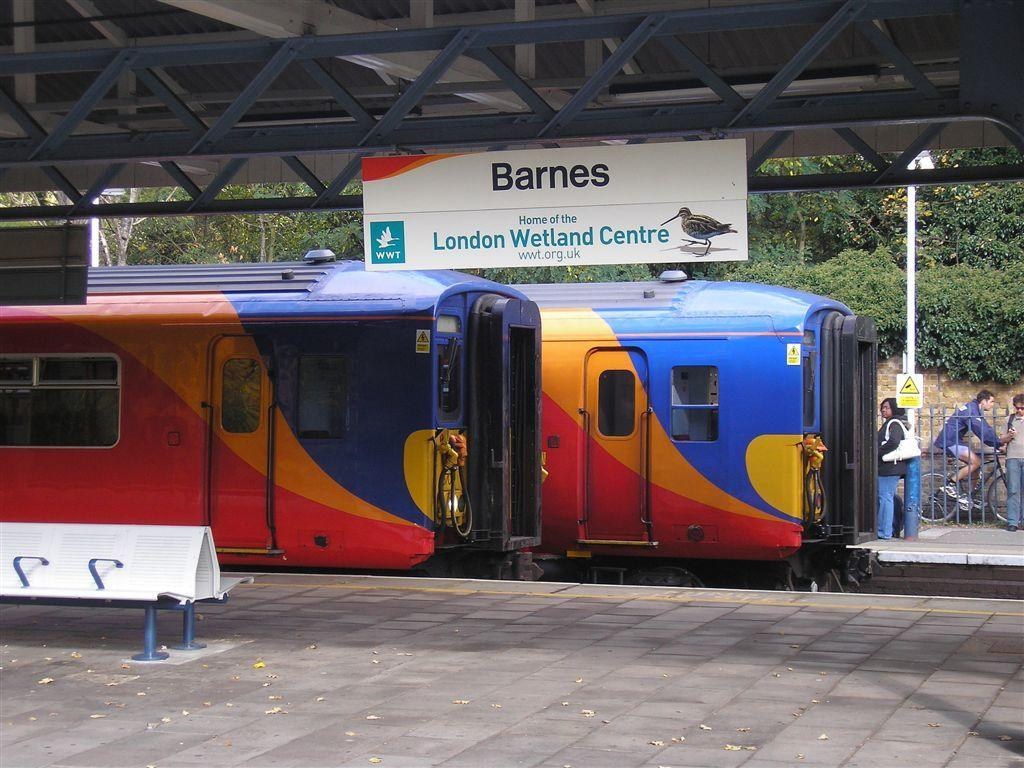<image>
Relay a brief, clear account of the picture shown. A train station  with a sign saying Barnes London Wetland Centre. 